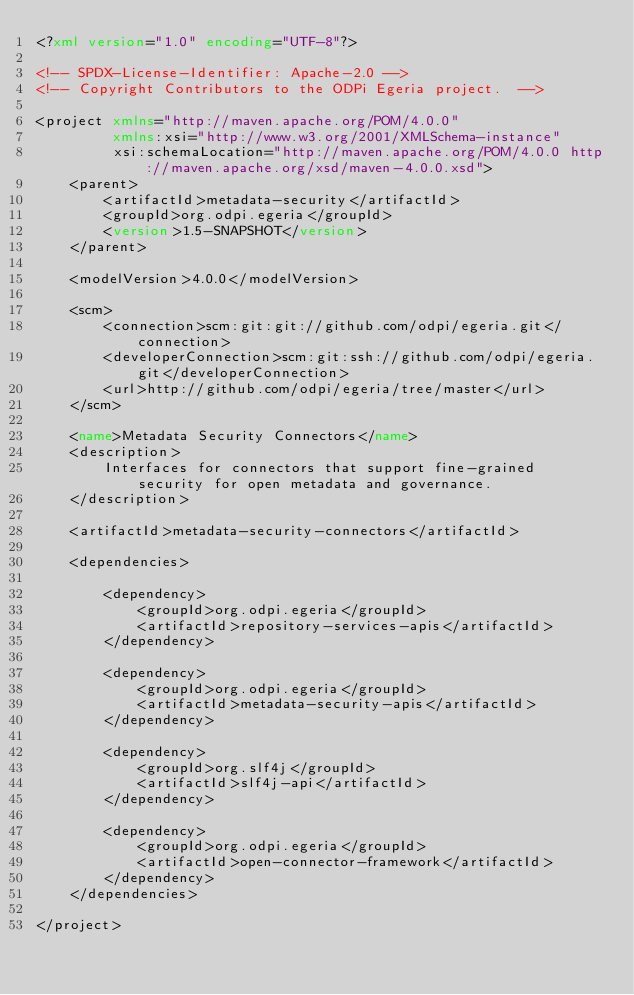<code> <loc_0><loc_0><loc_500><loc_500><_XML_><?xml version="1.0" encoding="UTF-8"?>

<!-- SPDX-License-Identifier: Apache-2.0 -->
<!-- Copyright Contributors to the ODPi Egeria project.  -->

<project xmlns="http://maven.apache.org/POM/4.0.0"
         xmlns:xsi="http://www.w3.org/2001/XMLSchema-instance"
         xsi:schemaLocation="http://maven.apache.org/POM/4.0.0 http://maven.apache.org/xsd/maven-4.0.0.xsd">
    <parent>
        <artifactId>metadata-security</artifactId>
        <groupId>org.odpi.egeria</groupId>
        <version>1.5-SNAPSHOT</version>
    </parent>

    <modelVersion>4.0.0</modelVersion>

    <scm>
        <connection>scm:git:git://github.com/odpi/egeria.git</connection>
        <developerConnection>scm:git:ssh://github.com/odpi/egeria.git</developerConnection>
        <url>http://github.com/odpi/egeria/tree/master</url>
    </scm>

    <name>Metadata Security Connectors</name>
    <description>
        Interfaces for connectors that support fine-grained security for open metadata and governance.
    </description>

    <artifactId>metadata-security-connectors</artifactId>

    <dependencies>

        <dependency>
            <groupId>org.odpi.egeria</groupId>
            <artifactId>repository-services-apis</artifactId>
        </dependency>

        <dependency>
            <groupId>org.odpi.egeria</groupId>
            <artifactId>metadata-security-apis</artifactId>
        </dependency>

        <dependency>
            <groupId>org.slf4j</groupId>
            <artifactId>slf4j-api</artifactId>
        </dependency>

        <dependency>
            <groupId>org.odpi.egeria</groupId>
            <artifactId>open-connector-framework</artifactId>
        </dependency>
    </dependencies>

</project>
</code> 